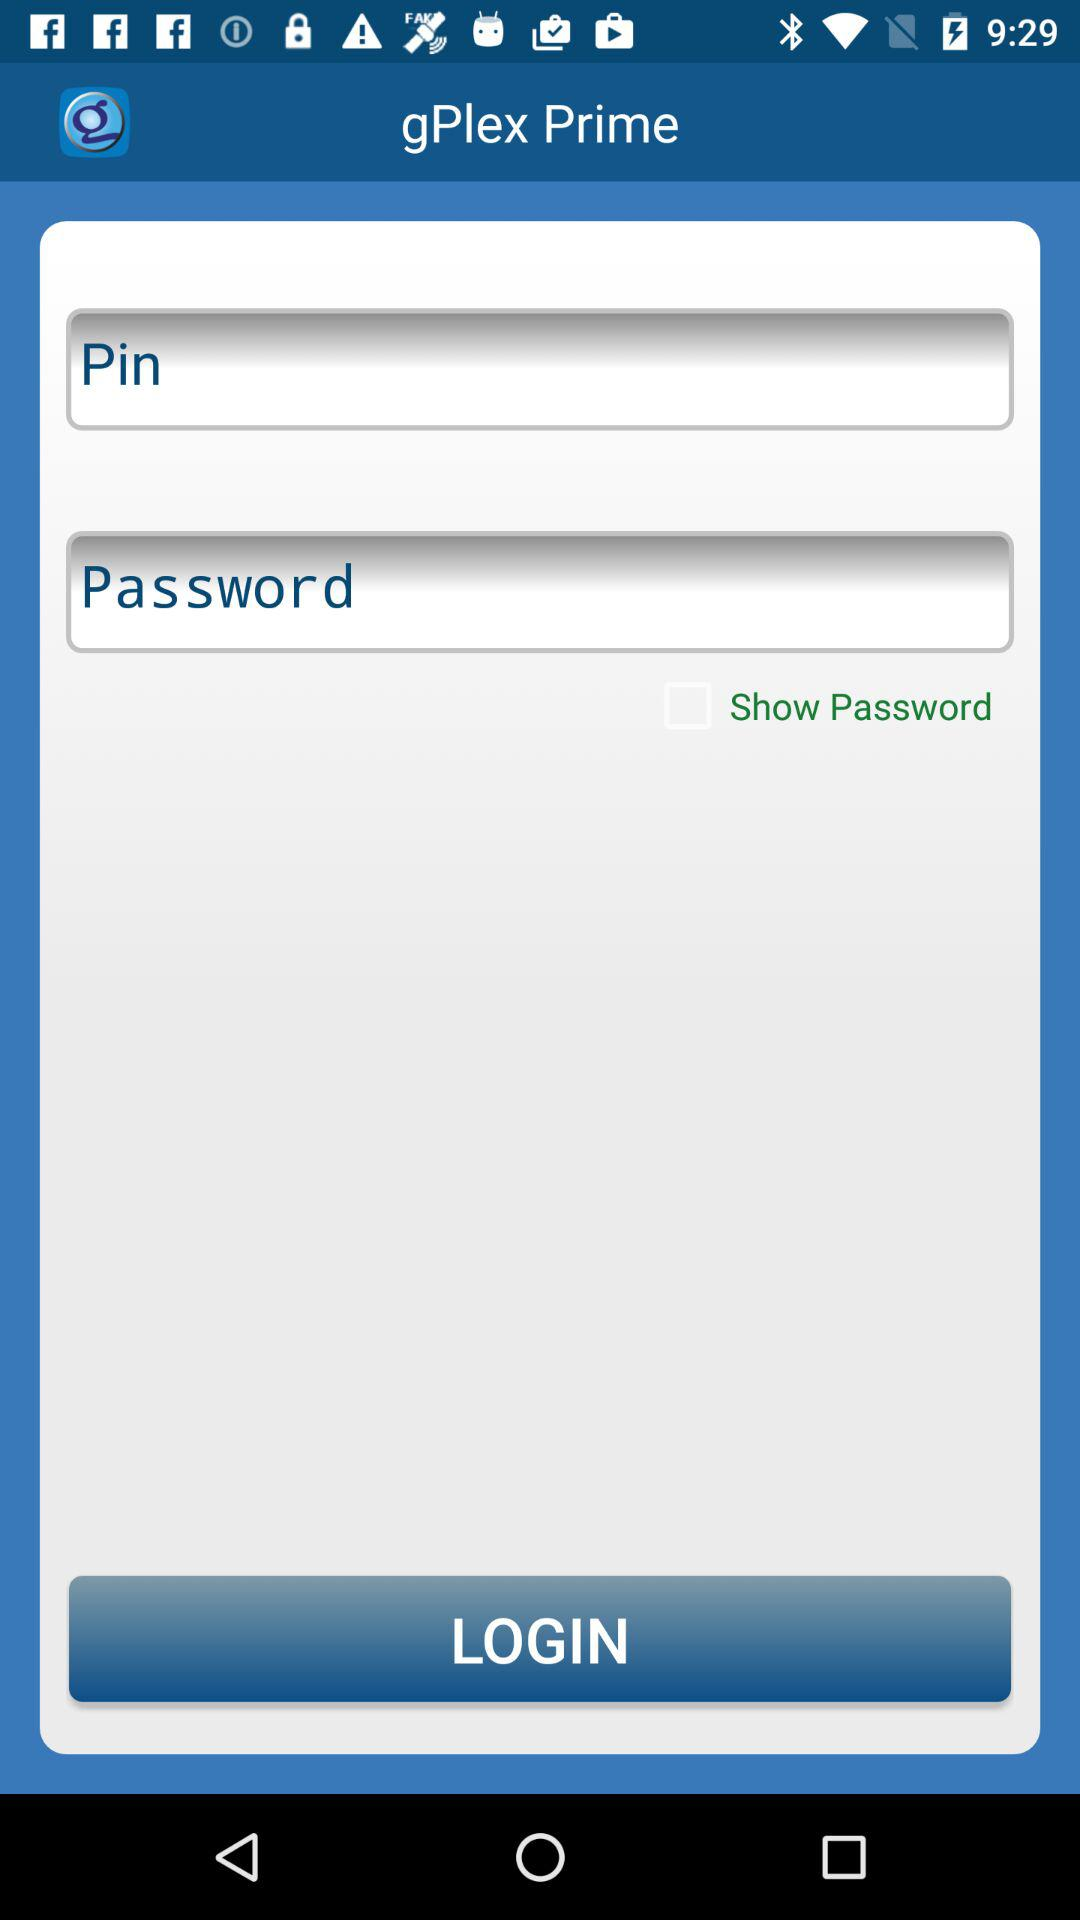What is the name of the application? The name of the application is "gPlex Prime". 